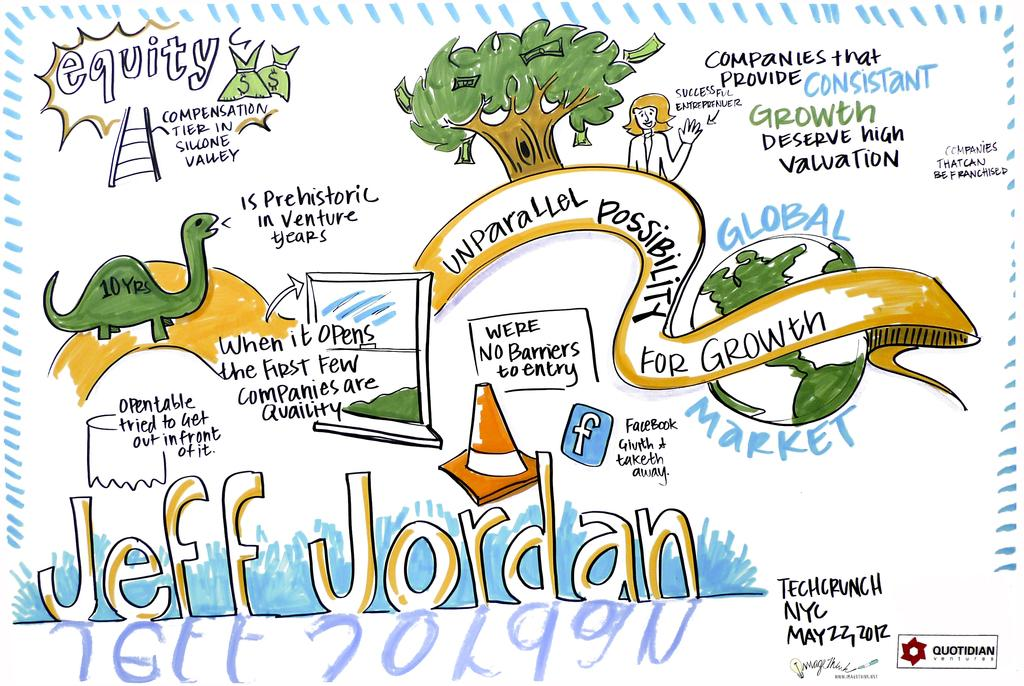What style is the image presented in? The image is a cartoon. What else can be found in the image besides the cartoon style? There is text written in the image and an image of a tree. What type of crime is being committed in the image? There is no crime depicted in the image; it is a cartoon with text and an image of a tree. Are there any masks present in the image? There are no masks present in the image. 